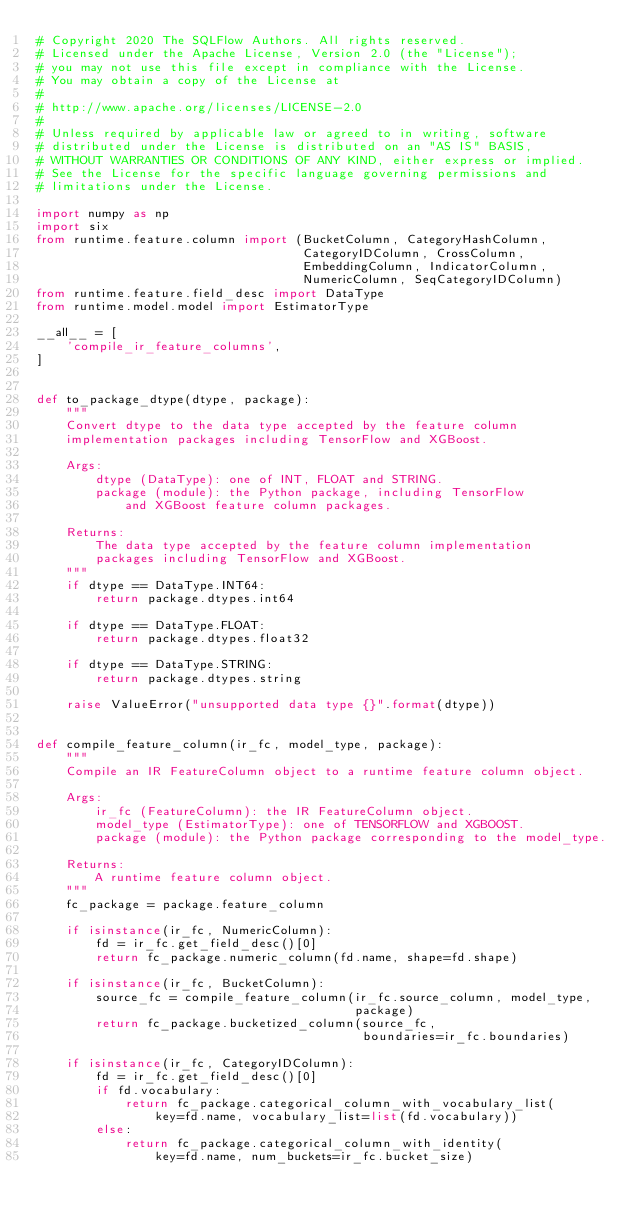Convert code to text. <code><loc_0><loc_0><loc_500><loc_500><_Python_># Copyright 2020 The SQLFlow Authors. All rights reserved.
# Licensed under the Apache License, Version 2.0 (the "License");
# you may not use this file except in compliance with the License.
# You may obtain a copy of the License at
#
# http://www.apache.org/licenses/LICENSE-2.0
#
# Unless required by applicable law or agreed to in writing, software
# distributed under the License is distributed on an "AS IS" BASIS,
# WITHOUT WARRANTIES OR CONDITIONS OF ANY KIND, either express or implied.
# See the License for the specific language governing permissions and
# limitations under the License.

import numpy as np
import six
from runtime.feature.column import (BucketColumn, CategoryHashColumn,
                                    CategoryIDColumn, CrossColumn,
                                    EmbeddingColumn, IndicatorColumn,
                                    NumericColumn, SeqCategoryIDColumn)
from runtime.feature.field_desc import DataType
from runtime.model.model import EstimatorType

__all__ = [
    'compile_ir_feature_columns',
]


def to_package_dtype(dtype, package):
    """
    Convert dtype to the data type accepted by the feature column
    implementation packages including TensorFlow and XGBoost.

    Args:
        dtype (DataType): one of INT, FLOAT and STRING.
        package (module): the Python package, including TensorFlow
            and XGBoost feature column packages.

    Returns:
        The data type accepted by the feature column implementation
        packages including TensorFlow and XGBoost.
    """
    if dtype == DataType.INT64:
        return package.dtypes.int64

    if dtype == DataType.FLOAT:
        return package.dtypes.float32

    if dtype == DataType.STRING:
        return package.dtypes.string

    raise ValueError("unsupported data type {}".format(dtype))


def compile_feature_column(ir_fc, model_type, package):
    """
    Compile an IR FeatureColumn object to a runtime feature column object.

    Args:
        ir_fc (FeatureColumn): the IR FeatureColumn object.
        model_type (EstimatorType): one of TENSORFLOW and XGBOOST.
        package (module): the Python package corresponding to the model_type.

    Returns:
        A runtime feature column object.
    """
    fc_package = package.feature_column

    if isinstance(ir_fc, NumericColumn):
        fd = ir_fc.get_field_desc()[0]
        return fc_package.numeric_column(fd.name, shape=fd.shape)

    if isinstance(ir_fc, BucketColumn):
        source_fc = compile_feature_column(ir_fc.source_column, model_type,
                                           package)
        return fc_package.bucketized_column(source_fc,
                                            boundaries=ir_fc.boundaries)

    if isinstance(ir_fc, CategoryIDColumn):
        fd = ir_fc.get_field_desc()[0]
        if fd.vocabulary:
            return fc_package.categorical_column_with_vocabulary_list(
                key=fd.name, vocabulary_list=list(fd.vocabulary))
        else:
            return fc_package.categorical_column_with_identity(
                key=fd.name, num_buckets=ir_fc.bucket_size)
</code> 